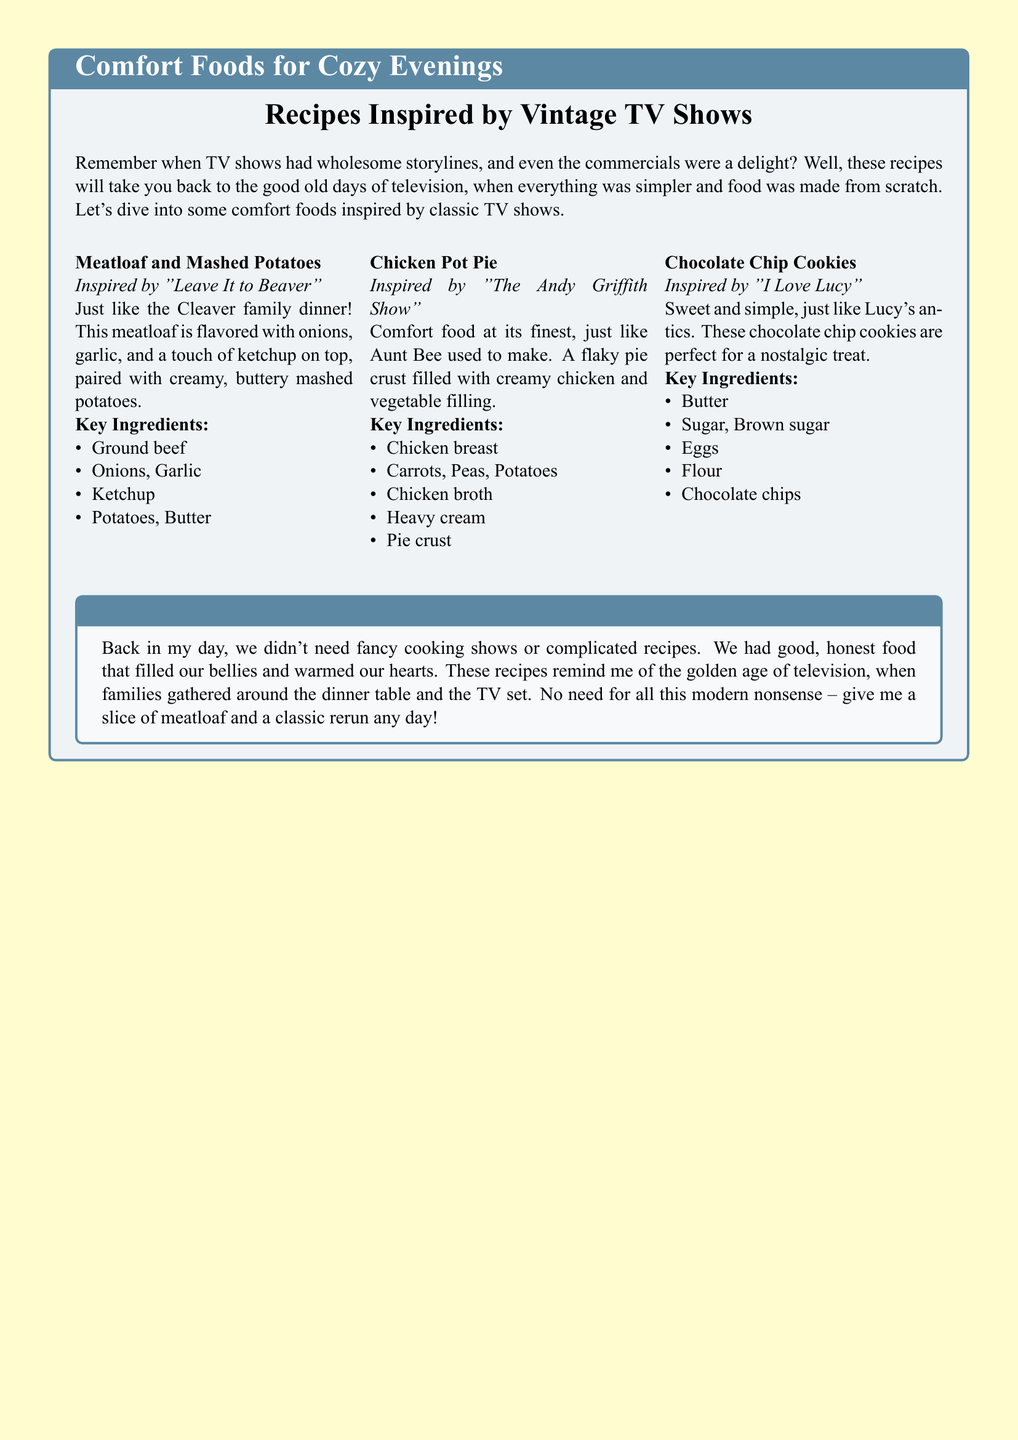What is the first recipe mentioned? The first recipe highlighted in the document is "Meatloaf and Mashed Potatoes."
Answer: Meatloaf and Mashed Potatoes Which TV show inspired the Chicken Pot Pie recipe? The Chicken Pot Pie recipe is inspired by "The Andy Griffith Show."
Answer: The Andy Griffith Show What is a key ingredient in Chocolate Chip Cookies? One of the key ingredients in Chocolate Chip Cookies is butter.
Answer: Butter How many recipes are listed in the document? The document lists a total of three recipes.
Answer: Three What does the grumpy old-timer think about modern cooking shows? The grumpy old-timer expresses disapproval of modern cooking shows.
Answer: Disapproval Which family is associated with the Meatloaf recipe? The Meatloaf recipe is associated with the Cleaver family.
Answer: Cleaver family What type of cuisine does this document focus on? The document focuses on comfort foods.
Answer: Comfort foods What does the note from the grumpy old-timer emphasize? The note emphasizes the nostalgia for simpler, honest food from the past.
Answer: Nostalgia for simpler food 